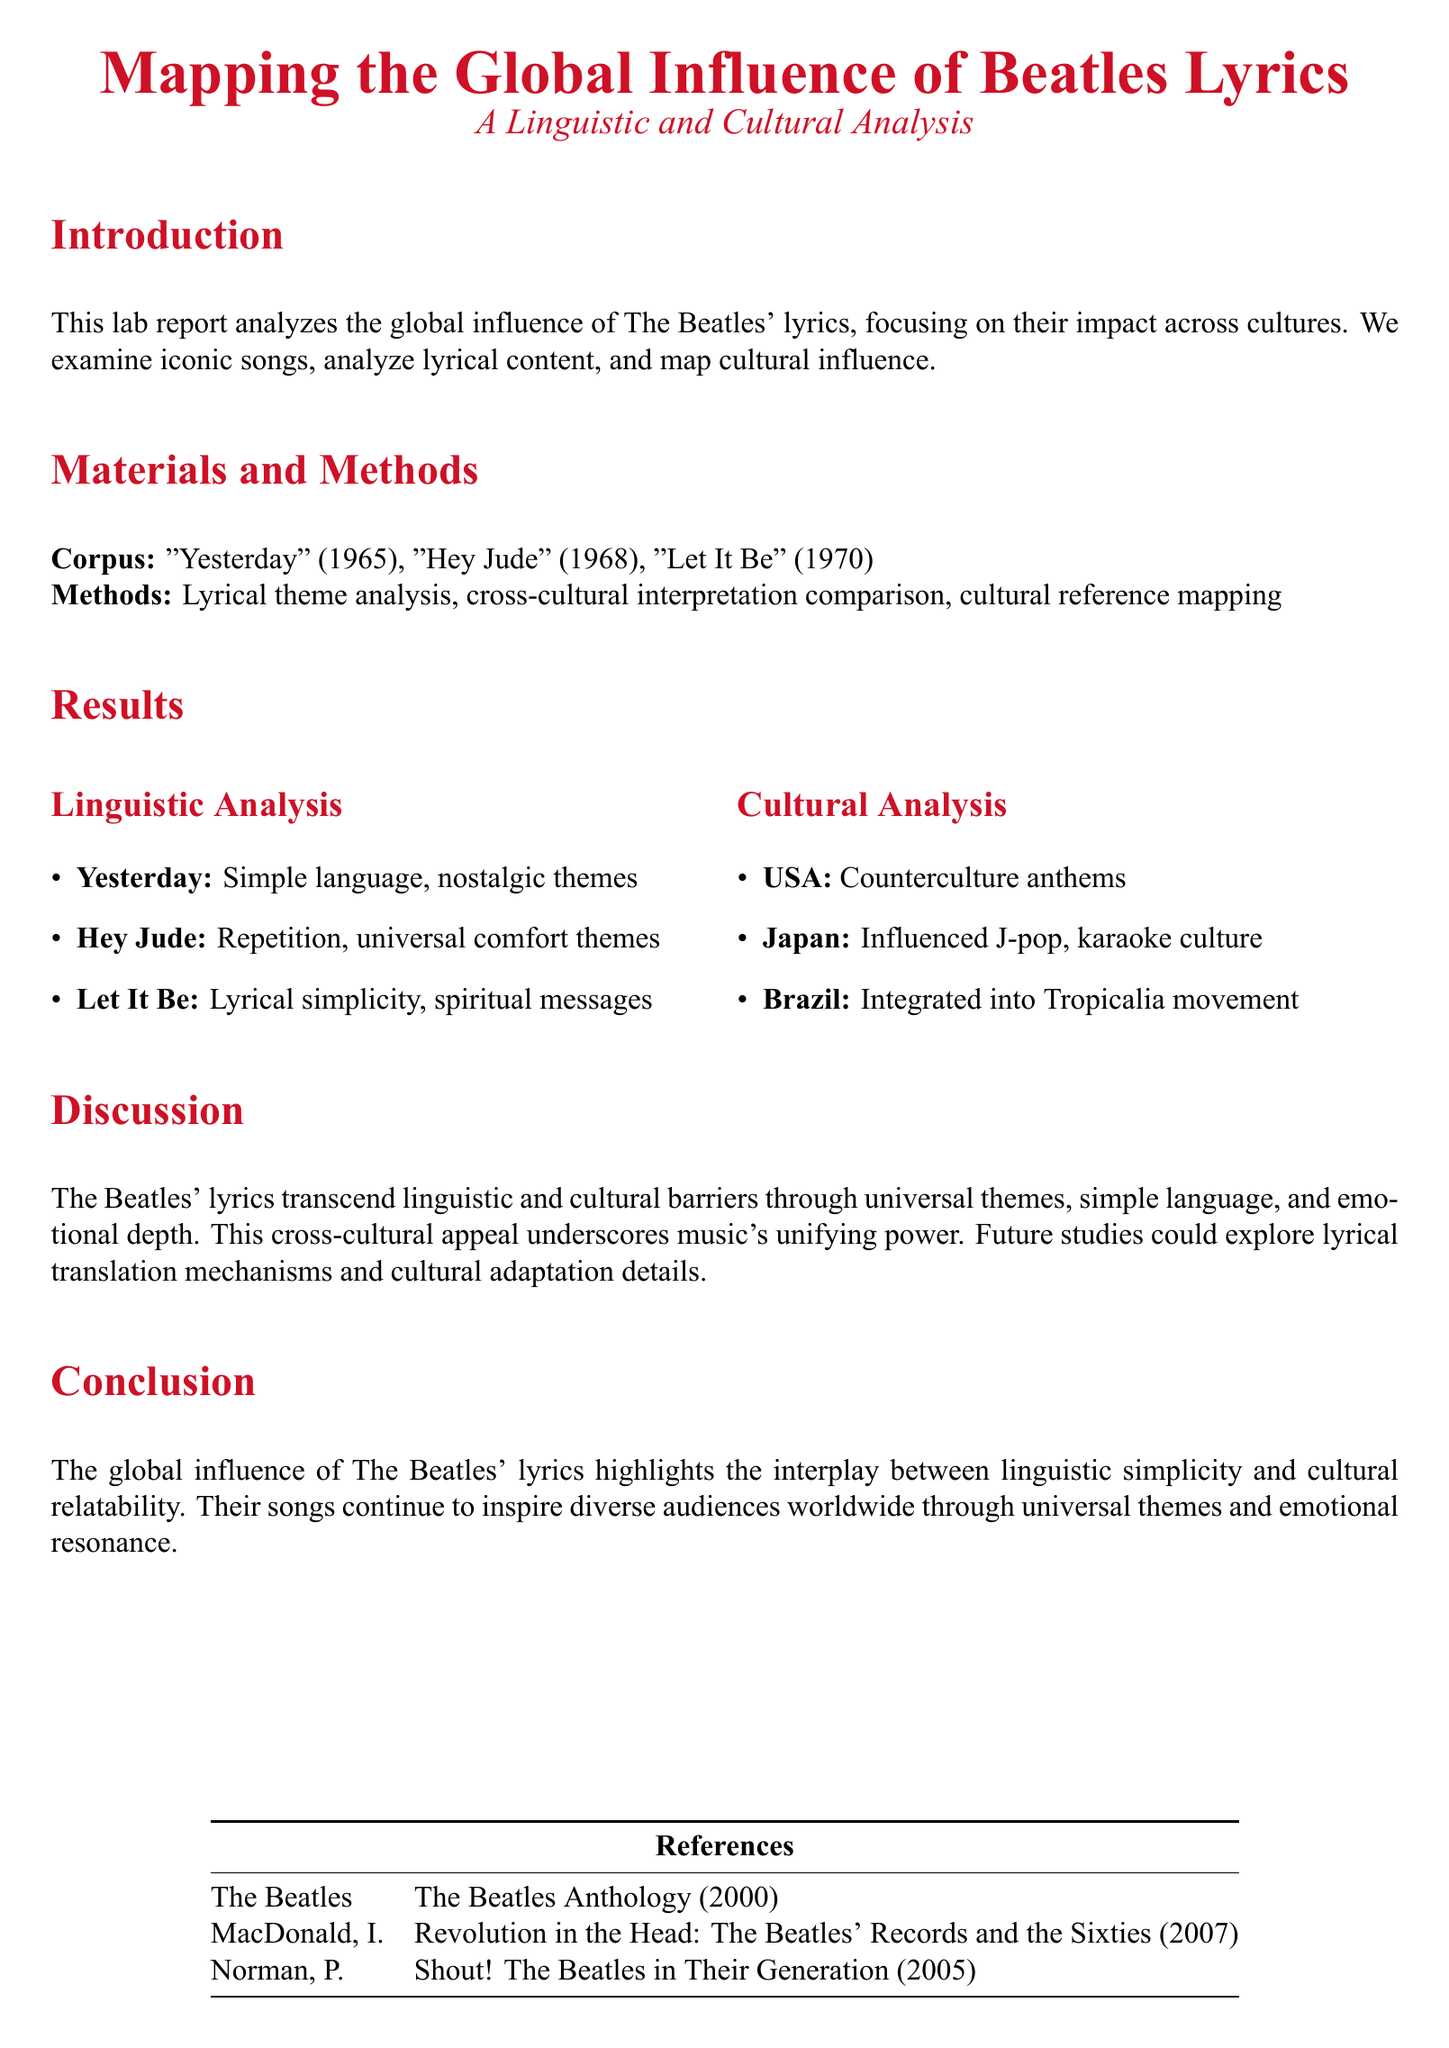What are the three songs analyzed in the report? The report lists "Yesterday," "Hey Jude," and "Let It Be" as the songs analyzed.
Answer: "Yesterday," "Hey Jude," "Let It Be" What year was "Let It Be" released? The report states that "Let It Be" was released in 1970.
Answer: 1970 What linguistic theme is associated with "Hey Jude"? The report mentions that "Hey Jude" is associated with repetition and universal comfort themes.
Answer: Repetition, universal comfort themes Which country is noted for the influence of The Beatles on their music genre? The report indicates that The Beatles influenced Japan's J-pop.
Answer: Japan What is the conclusion about the global influence of The Beatles' lyrics? The conclusion highlights the interplay between linguistic simplicity and cultural relatability.
Answer: Interplay between linguistic simplicity and cultural relatability How many references are listed in the document? The document includes a total of three references.
Answer: 3 What is the primary method used in the analysis? The primary method outlined in the report is lyrical theme analysis.
Answer: Lyrical theme analysis What kind of messages are highlighted in "Let It Be"? The report indicates that "Let It Be" contains spiritual messages.
Answer: Spiritual messages 